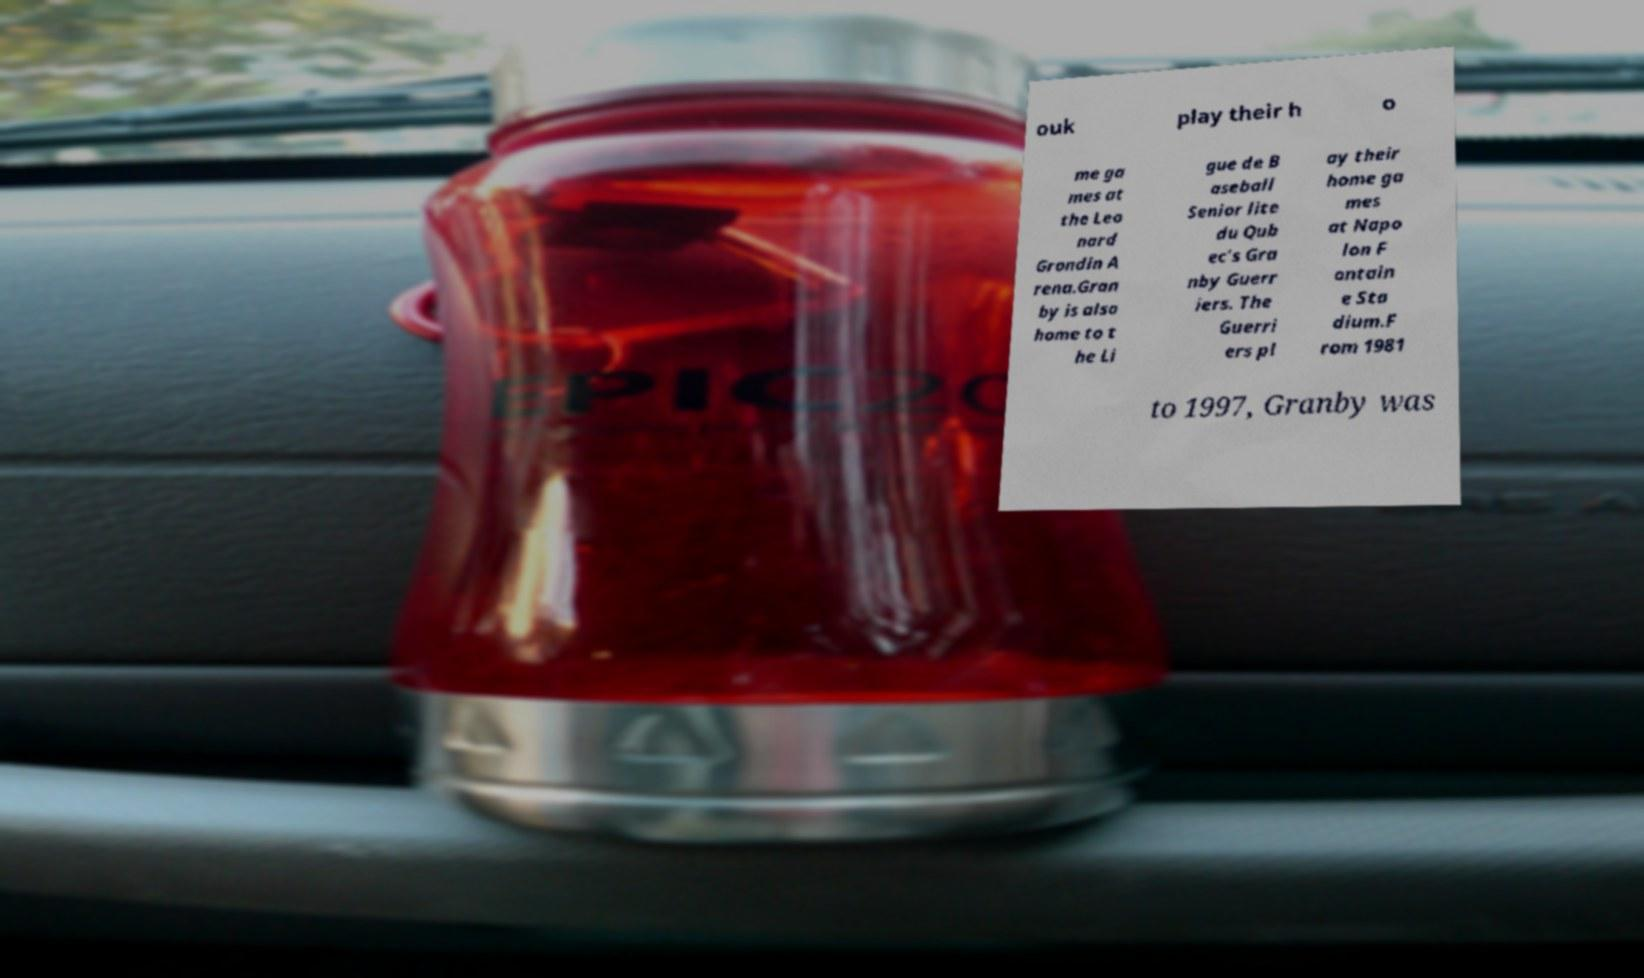Can you read and provide the text displayed in the image?This photo seems to have some interesting text. Can you extract and type it out for me? ouk play their h o me ga mes at the Leo nard Grondin A rena.Gran by is also home to t he Li gue de B aseball Senior lite du Qub ec's Gra nby Guerr iers. The Guerri ers pl ay their home ga mes at Napo lon F ontain e Sta dium.F rom 1981 to 1997, Granby was 